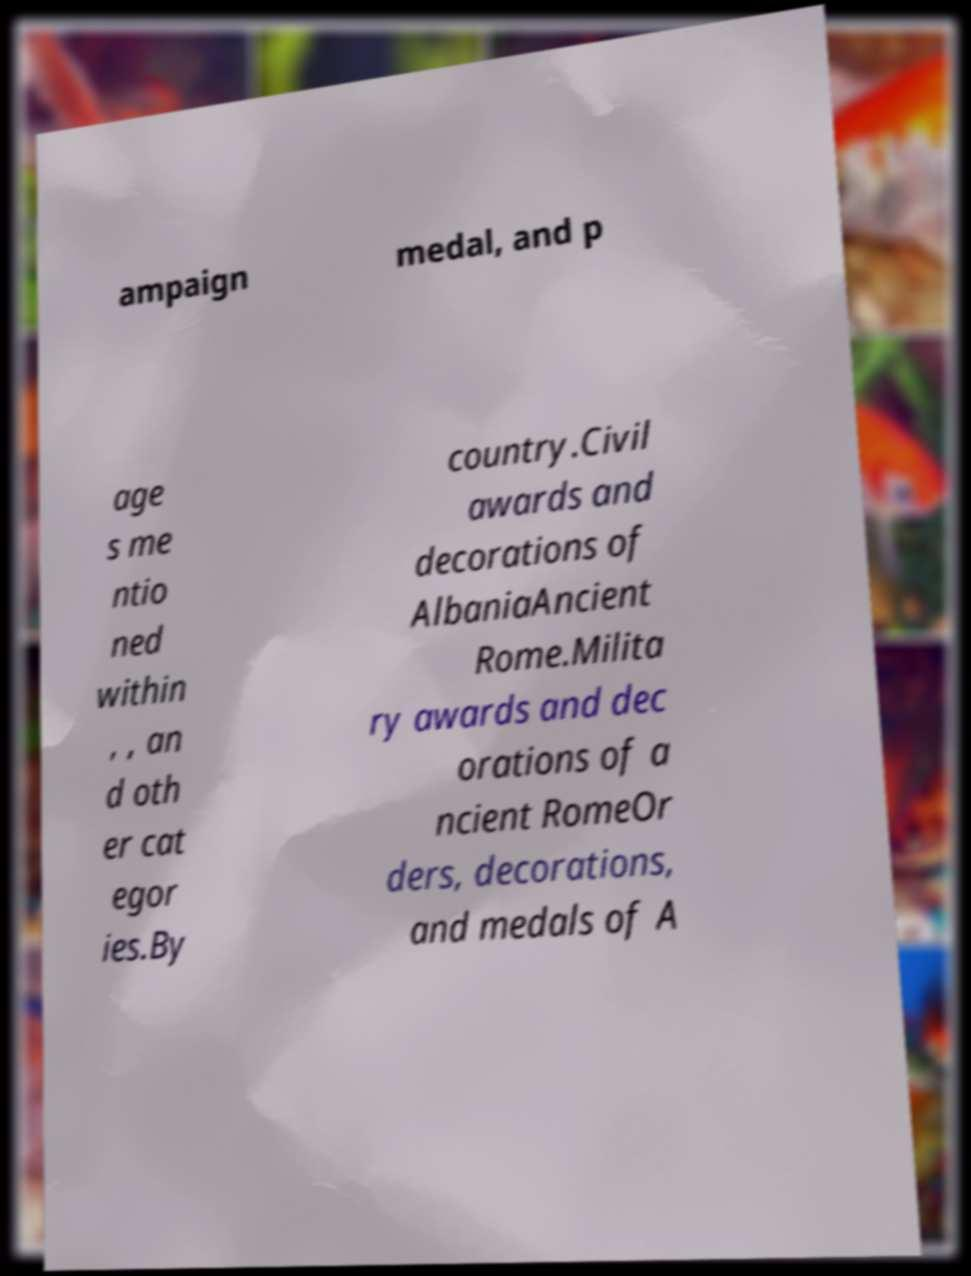Can you read and provide the text displayed in the image?This photo seems to have some interesting text. Can you extract and type it out for me? ampaign medal, and p age s me ntio ned within , , an d oth er cat egor ies.By country.Civil awards and decorations of AlbaniaAncient Rome.Milita ry awards and dec orations of a ncient RomeOr ders, decorations, and medals of A 